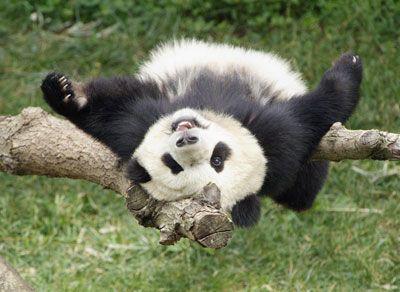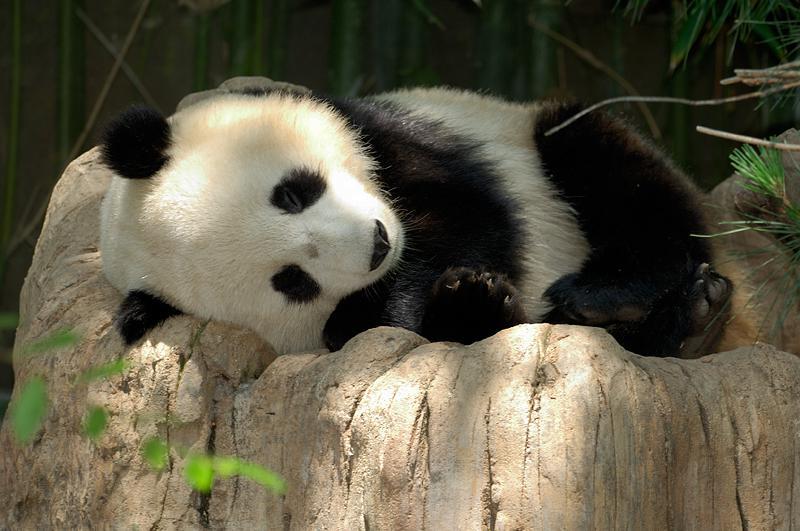The first image is the image on the left, the second image is the image on the right. For the images shown, is this caption "The right image features one panda resting on its side on an elevated surface with its head to the left." true? Answer yes or no. Yes. 